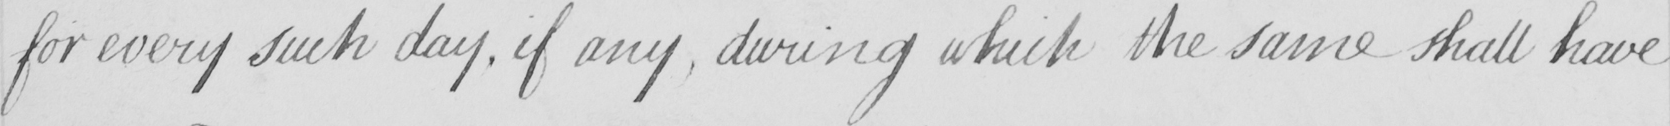What text is written in this handwritten line? for every such day , if any , during which the same shall have 